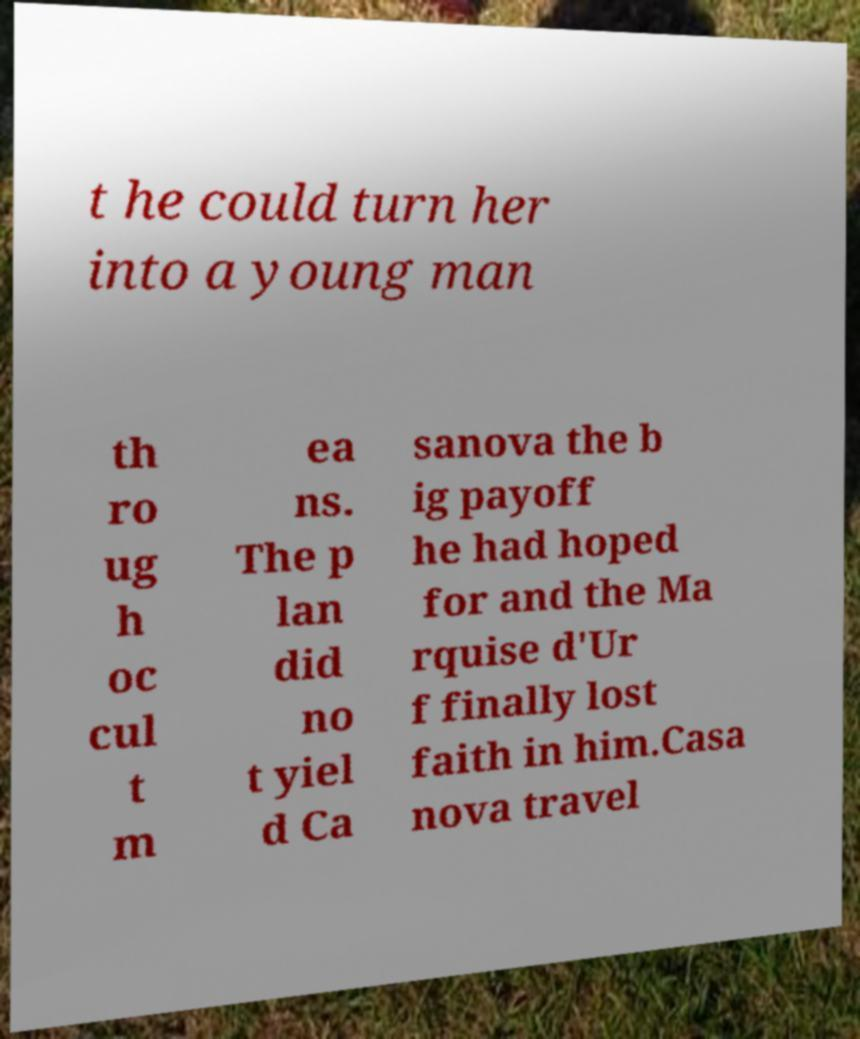Could you extract and type out the text from this image? t he could turn her into a young man th ro ug h oc cul t m ea ns. The p lan did no t yiel d Ca sanova the b ig payoff he had hoped for and the Ma rquise d'Ur f finally lost faith in him.Casa nova travel 